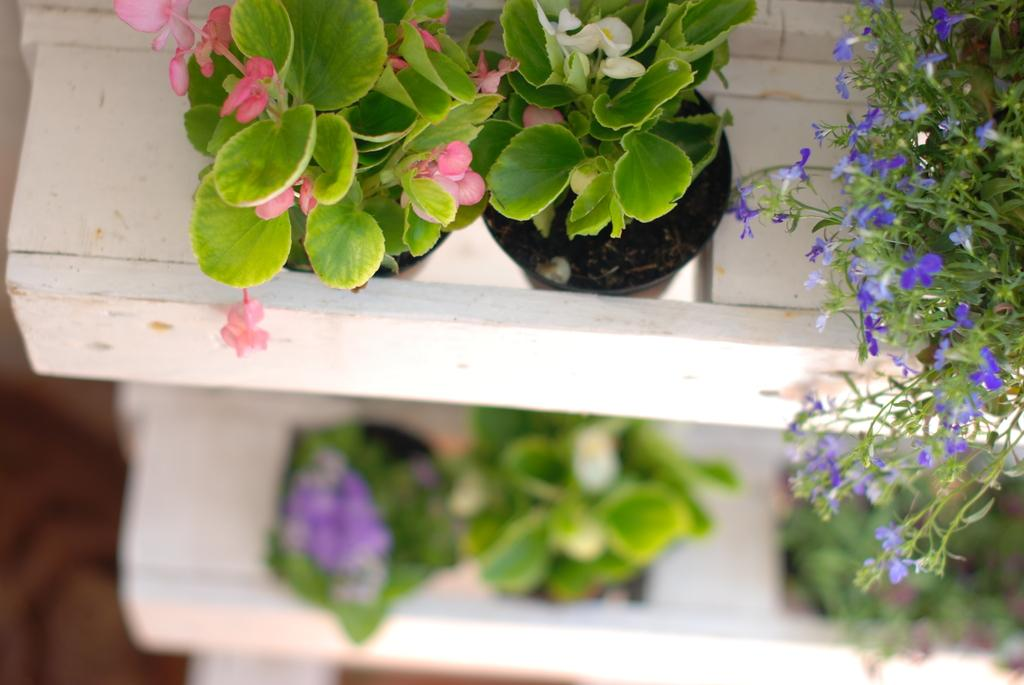What type of plants are in the image? There are house plants in the image. Where are the house plants located? The house plants are placed on shelves. What type of fish can be seen swimming in the image? There are no fish present in the image; it features house plants on shelves. What is the cause of the thunder in the image? There is no thunder present in the image; it only contains house plants on shelves. 